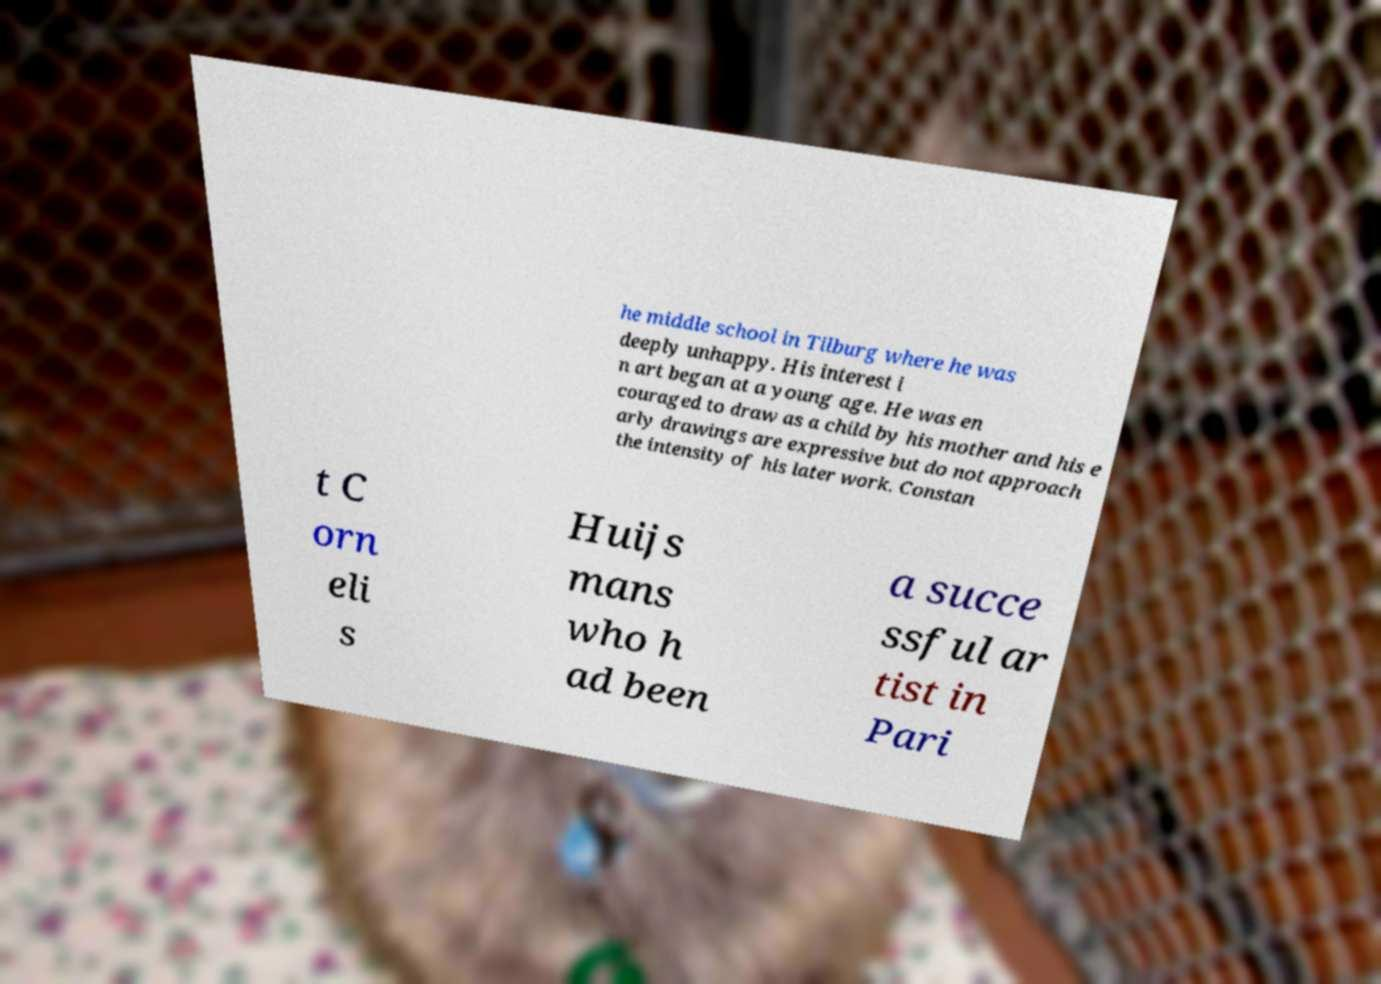Please identify and transcribe the text found in this image. he middle school in Tilburg where he was deeply unhappy. His interest i n art began at a young age. He was en couraged to draw as a child by his mother and his e arly drawings are expressive but do not approach the intensity of his later work. Constan t C orn eli s Huijs mans who h ad been a succe ssful ar tist in Pari 